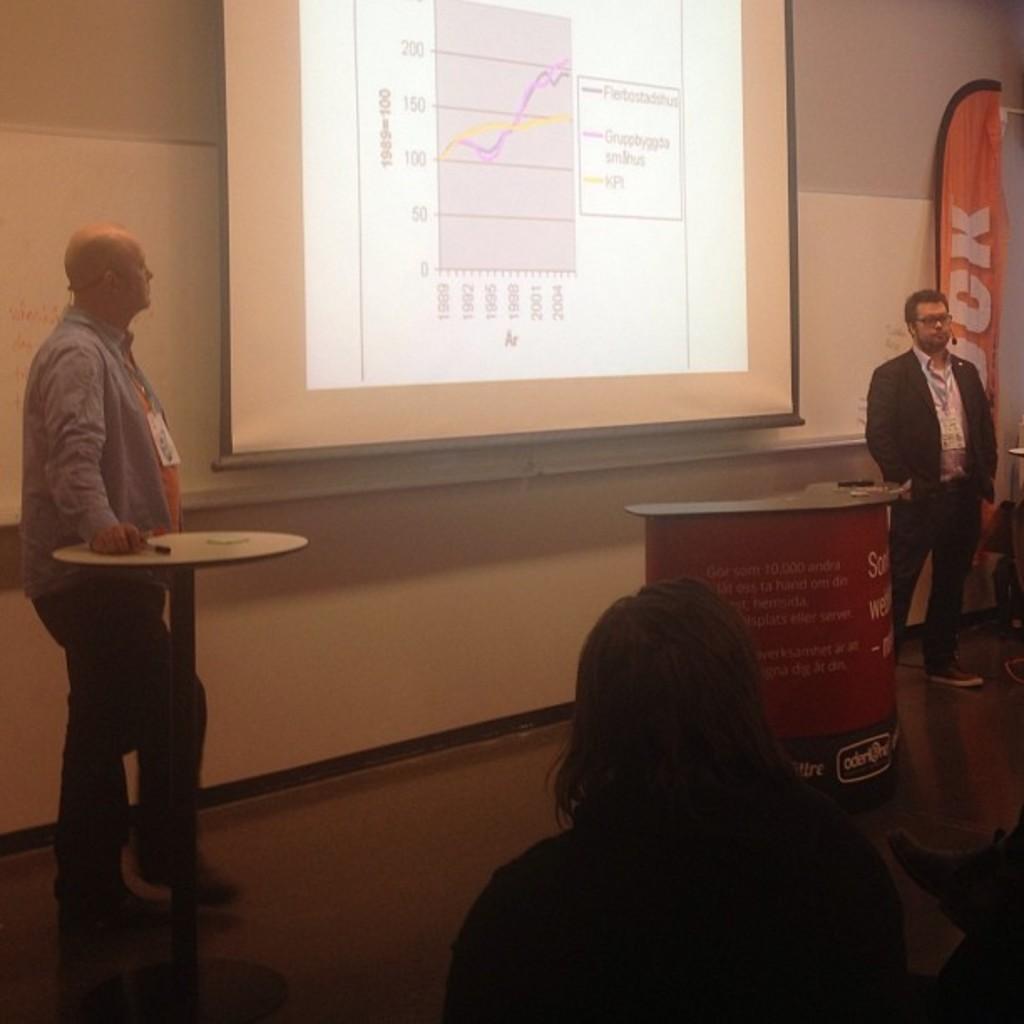How would you summarize this image in a sentence or two? In this image I can see group of people standing and the person is wearing black blazer, white shirt and the person at left is wearing blue shirt, black pant. Background I can see a projector screen and I can see an orange color banner and the wall is in white color. 